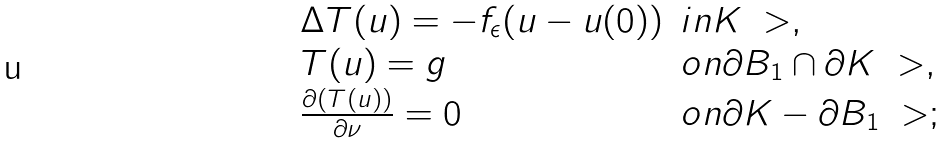<formula> <loc_0><loc_0><loc_500><loc_500>\begin{array} { l l } \Delta T ( u ) = - f _ { \epsilon } ( u - u ( 0 ) ) & i n K \ > , \\ T ( u ) = g & o n \partial B _ { 1 } \cap \partial K \ > , \\ \frac { \partial ( T ( u ) ) } { \partial \nu } = 0 & o n \partial K - \partial B _ { 1 } \ > ; \end{array}</formula> 